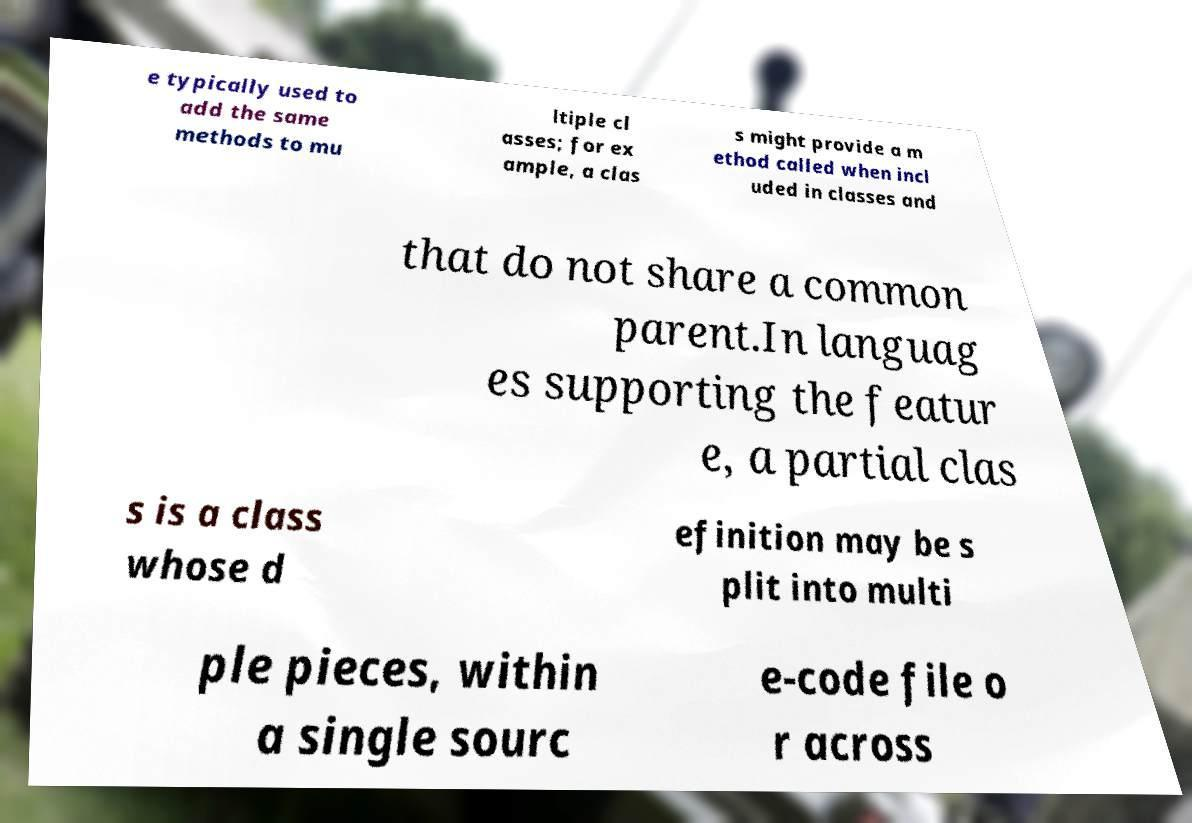What messages or text are displayed in this image? I need them in a readable, typed format. e typically used to add the same methods to mu ltiple cl asses; for ex ample, a clas s might provide a m ethod called when incl uded in classes and that do not share a common parent.In languag es supporting the featur e, a partial clas s is a class whose d efinition may be s plit into multi ple pieces, within a single sourc e-code file o r across 